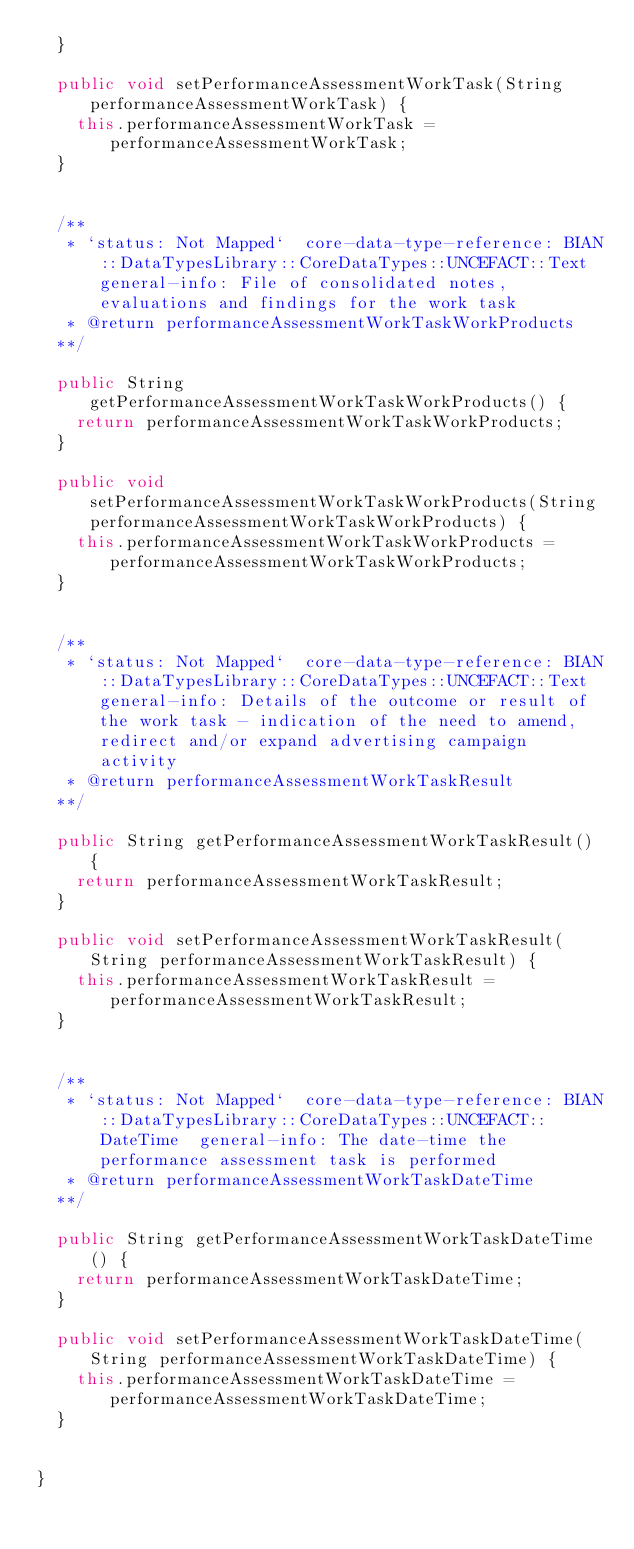Convert code to text. <code><loc_0><loc_0><loc_500><loc_500><_Java_>  }

  public void setPerformanceAssessmentWorkTask(String performanceAssessmentWorkTask) {
    this.performanceAssessmentWorkTask = performanceAssessmentWorkTask;
  }


  /**
   * `status: Not Mapped`  core-data-type-reference: BIAN::DataTypesLibrary::CoreDataTypes::UNCEFACT::Text  general-info: File of consolidated notes, evaluations and findings for the work task 
   * @return performanceAssessmentWorkTaskWorkProducts
  **/

  public String getPerformanceAssessmentWorkTaskWorkProducts() {
    return performanceAssessmentWorkTaskWorkProducts;
  }

  public void setPerformanceAssessmentWorkTaskWorkProducts(String performanceAssessmentWorkTaskWorkProducts) {
    this.performanceAssessmentWorkTaskWorkProducts = performanceAssessmentWorkTaskWorkProducts;
  }


  /**
   * `status: Not Mapped`  core-data-type-reference: BIAN::DataTypesLibrary::CoreDataTypes::UNCEFACT::Text  general-info: Details of the outcome or result of the work task - indication of the need to amend, redirect and/or expand advertising campaign activity 
   * @return performanceAssessmentWorkTaskResult
  **/

  public String getPerformanceAssessmentWorkTaskResult() {
    return performanceAssessmentWorkTaskResult;
  }

  public void setPerformanceAssessmentWorkTaskResult(String performanceAssessmentWorkTaskResult) {
    this.performanceAssessmentWorkTaskResult = performanceAssessmentWorkTaskResult;
  }


  /**
   * `status: Not Mapped`  core-data-type-reference: BIAN::DataTypesLibrary::CoreDataTypes::UNCEFACT::DateTime  general-info: The date-time the performance assessment task is performed 
   * @return performanceAssessmentWorkTaskDateTime
  **/

  public String getPerformanceAssessmentWorkTaskDateTime() {
    return performanceAssessmentWorkTaskDateTime;
  }

  public void setPerformanceAssessmentWorkTaskDateTime(String performanceAssessmentWorkTaskDateTime) {
    this.performanceAssessmentWorkTaskDateTime = performanceAssessmentWorkTaskDateTime;
  }


}

</code> 